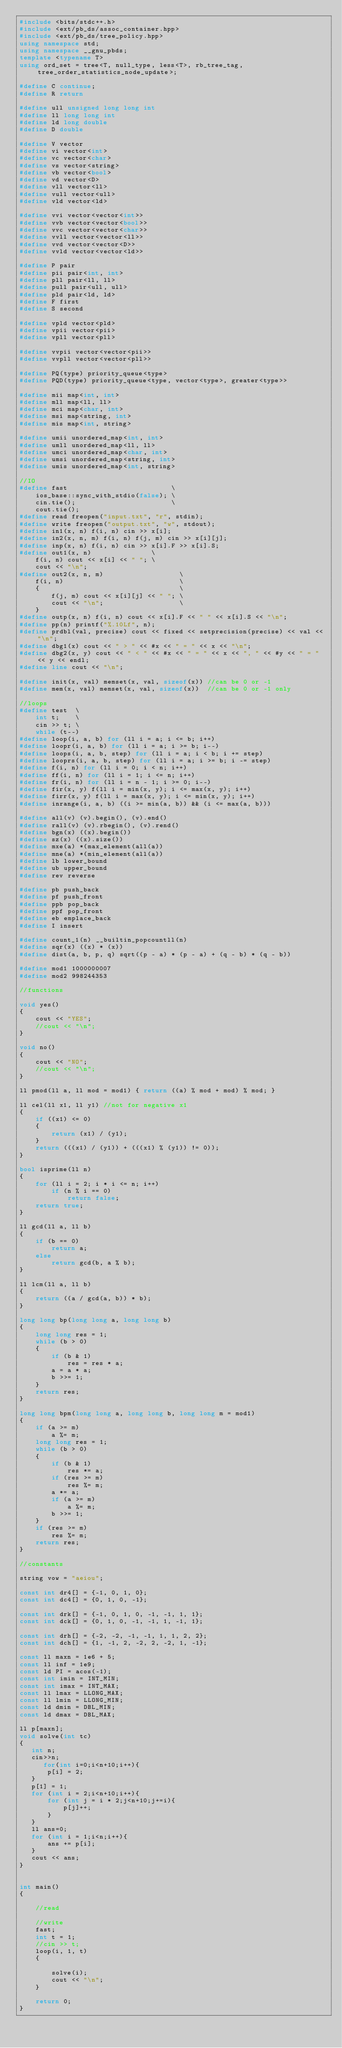Convert code to text. <code><loc_0><loc_0><loc_500><loc_500><_C++_>#include <bits/stdc++.h>
#include <ext/pb_ds/assoc_container.hpp>
#include <ext/pb_ds/tree_policy.hpp>
using namespace std;
using namespace __gnu_pbds;
template <typename T>
using ord_set = tree<T, null_type, less<T>, rb_tree_tag, tree_order_statistics_node_update>;

#define C continue;
#define R return

#define ull unsigned long long int
#define ll long long int
#define ld long double
#define D double

#define V vector
#define vi vector<int>
#define vc vector<char>
#define vs vector<string>
#define vb vector<bool>
#define vd vector<D>
#define vll vector<ll>
#define vull vector<ull>
#define vld vector<ld>

#define vvi vector<vector<int>>
#define vvb vector<vector<bool>>
#define vvc vector<vector<char>>
#define vvll vector<vector<ll>>
#define vvd vector<vector<D>>
#define vvld vector<vector<ld>>

#define P pair
#define pii pair<int, int>
#define pll pair<ll, ll>
#define pull pair<ull, ull>
#define pld pair<ld, ld>
#define F first
#define S second

#define vpld vector<pld>
#define vpii vector<pii>
#define vpll vector<pll>

#define vvpii vector<vector<pii>>
#define vvpll vector<vector<pll>>

#define PQ(type) priority_queue<type>
#define PQD(type) priority_queue<type, vector<type>, greater<type>>

#define mii map<int, int>
#define mll map<ll, ll>
#define mci map<char, int>
#define msi map<string, int>
#define mis map<int, string>

#define umii unordered_map<int, int>
#define umll unordered_map<ll, ll>
#define umci unordered_map<char, int>
#define umsi unordered_map<string, int>
#define umis unordered_map<int, string>

//IO
#define fast                          \
    ios_base::sync_with_stdio(false); \
    cin.tie();                        \
    cout.tie();
#define read freopen("input.txt", "r", stdin);
#define write freopen("output.txt", "w", stdout);
#define in1(x, n) f(i, n) cin >> x[i];
#define in2(x, n, m) f(i, n) f(j, m) cin >> x[i][j];
#define inp(x, n) f(i, n) cin >> x[i].F >> x[i].S;
#define out1(x, n)               \
    f(i, n) cout << x[i] << " "; \
    cout << "\n";
#define out2(x, n, m)                   \
    f(i, n)                             \
    {                                   \
        f(j, m) cout << x[i][j] << " "; \
        cout << "\n";                   \
    }
#define outp(x, n) f(i, n) cout << x[i].F << " " << x[i].S << "\n";
#define pp(n) printf("%.10Lf", n);
#define prdbl(val, precise) cout << fixed << setprecision(precise) << val << "\n";
#define dbg1(x) cout << " > " << #x << " = " << x << "\n";
#define dbg2(x, y) cout << " < " << #x << " = " << x << ", " << #y << " = " << y << endl;
#define line cout << "\n";

#define init(x, val) memset(x, val, sizeof(x)) //can be 0 or -1
#define mem(x, val) memset(x, val, sizeof(x))  //can be 0 or -1 only

//loops
#define test  \
    int t;    \
    cin >> t; \
    while (t--)
#define loop(i, a, b) for (ll i = a; i <= b; i++)
#define loopr(i, a, b) for (ll i = a; i >= b; i--)
#define loops(i, a, b, step) for (ll i = a; i < b; i += step)
#define looprs(i, a, b, step) for (ll i = a; i >= b; i -= step)
#define f(i, n) for (ll i = 0; i < n; i++)
#define ff(i, n) for (ll i = 1; i <= n; i++)
#define fr(i, n) for (ll i = n - 1; i >= 0; i--)
#define fir(x, y) f(ll i = min(x, y); i <= max(x, y); i++)
#define firr(x, y) f(ll i = max(x, y); i <= min(x, y); i++)
#define inrange(i, a, b) ((i >= min(a, b)) && (i <= max(a, b)))

#define all(v) (v).begin(), (v).end()
#define rall(v) (v).rbegin(), (v).rend()
#define bgn(x) ((x).begin())
#define sz(x) ((x).size())
#define mxe(a) *(max_element(all(a))
#define mne(a) *(min_element(all(a))
#define lb lower_bound
#define ub upper_bound
#define rev reverse

#define pb push_back
#define pf push_front
#define ppb pop_back
#define ppf pop_front
#define eb emplace_back
#define I insert

#define count_1(n) __builtin_popcountll(n)
#define sqr(x) ((x) * (x))
#define dist(a, b, p, q) sqrt((p - a) * (p - a) + (q - b) * (q - b))

#define mod1 1000000007
#define mod2 998244353

//functions

void yes()
{
    cout << "YES";
    //cout << "\n";
}

void no()
{
    cout << "NO";
    //cout << "\n";
}

ll pmod(ll a, ll mod = mod1) { return ((a) % mod + mod) % mod; }

ll cel(ll x1, ll y1) //not for negative x1
{
    if ((x1) <= 0)
    {
        return (x1) / (y1);
    }
    return (((x1) / (y1)) + (((x1) % (y1)) != 0));
}

bool isprime(ll n)
{
    for (ll i = 2; i * i <= n; i++)
        if (n % i == 0)
            return false;
    return true;
}

ll gcd(ll a, ll b)
{
    if (b == 0)
        return a;
    else
        return gcd(b, a % b);
}

ll lcm(ll a, ll b)
{
    return ((a / gcd(a, b)) * b);
}

long long bp(long long a, long long b)
{
    long long res = 1;
    while (b > 0)
    {
        if (b & 1)
            res = res * a;
        a = a * a;
        b >>= 1;
    }
    return res;
}

long long bpm(long long a, long long b, long long m = mod1)
{
    if (a >= m)
        a %= m;
    long long res = 1;
    while (b > 0)
    {
        if (b & 1)
            res *= a;
        if (res >= m)
            res %= m;
        a *= a;
        if (a >= m)
            a %= m;
        b >>= 1;
    }
    if (res >= m)
        res %= m;
    return res;
}

//constants

string vow = "aeiou";

const int dr4[] = {-1, 0, 1, 0};
const int dc4[] = {0, 1, 0, -1};

const int drk[] = {-1, 0, 1, 0, -1, -1, 1, 1};
const int dck[] = {0, 1, 0, -1, -1, 1, -1, 1};

const int drh[] = {-2, -2, -1, -1, 1, 1, 2, 2};
const int dch[] = {1, -1, 2, -2, 2, -2, 1, -1};

const ll maxn = 1e6 + 5;
const ll inf = 1e9;
const ld PI = acos(-1);
const int imin = INT_MIN;
const int imax = INT_MAX;
const ll lmax = LLONG_MAX;
const ll lmin = LLONG_MIN;
const ld dmin = DBL_MIN;
const ld dmax = DBL_MAX;

ll p[maxn];
void solve(int tc)
{
   int n;
   cin>>n;
      for(int i=0;i<n+10;i++){
       p[i] = 2;
   }
   p[1] = 1;
   for (int i = 2;i<n+10;i++){
       for (int j = i * 2;j<n+10;j+=i){
           p[j]++;
       }
   }
   ll ans=0;
   for (int i = 1;i<n;i++){
       ans += p[i];
   }
   cout << ans;
}


int main()
{

    //read

    //write
    fast;
    int t = 1;
    //cin >> t;
    loop(i, 1, t)
    {

        solve(i);
        cout << "\n";
    }

    return 0;
}</code> 